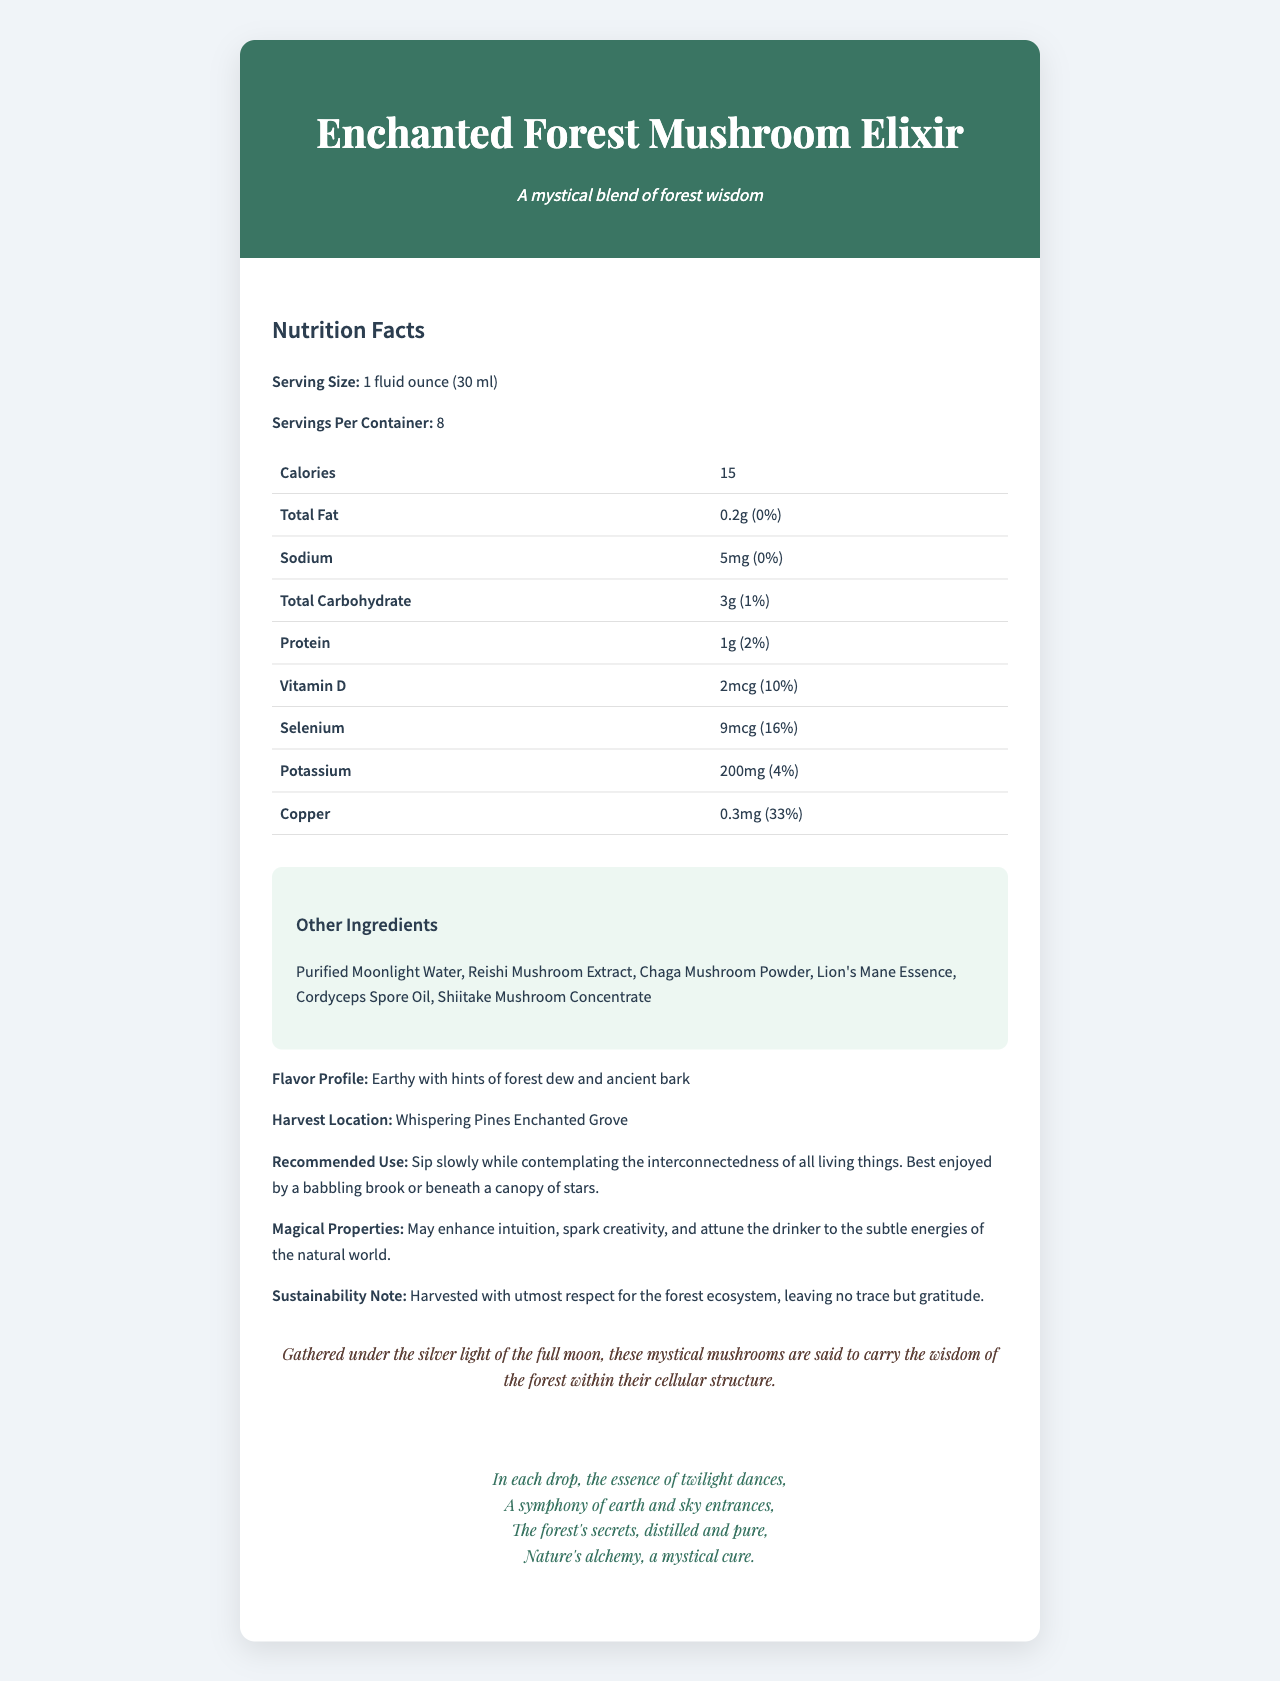What is the serving size of the Enchanted Forest Mushroom Elixir? The document lists the serving size as "1 fluid ounce (30 ml)".
Answer: 1 fluid ounce (30 ml) How many servings are there per container of the Enchanted Forest Mushroom Elixir? The document states that there are 8 servings per container.
Answer: 8 What is the calorie count per serving? The document specifies that there are 15 calories per serving.
Answer: 15 List three other ingredients in the Enchanted Forest Mushroom Elixir. These ingredients are listed under "Other Ingredients".
Answer: Purified Moonlight Water, Reishi Mushroom Extract, Chaga Mushroom Powder What are the suggested magical properties of the Enchanted Forest Mushroom Elixir? The document mentions these properties under "Magical Properties".
Answer: May enhance intuition, spark creativity, and attune the drinker to the subtle energies of the natural world. Which vitamin or mineral has the highest daily value percentage in the Enchanted Forest Mushroom Elixir? A. Vitamin D B. Selenium C. Potassium D. Copper The document shows that Copper has a daily value of 33%, which is the highest among the listed vitamins and minerals.
Answer: D. Copper How much protein is present per serving of the Enchanted Forest Mushroom Elixir? A. 0.2g B. 1g C. 2mcg D. 200mg The document lists 1 gram of protein per serving.
Answer: B. 1g Does the Enchanted Forest Mushroom Elixir contain fiber? The nutrition facts do not mention fiber.
Answer: No Is harvesting the Enchanted Forest Mushroom Elixir done sustainably? The sustainability note states that it was harvested with utmost respect for the forest ecosystem, leaving no trace but gratitude.
Answer: Yes Summarize the Enchanted Forest Mushroom Elixir document. The document details the nutritional information, ingredients, flavor profile, and magical properties of the Enchanted Forest Mushroom Elixir. It highlights sustainable practices and presents the product with an aura of enchantment.
Answer: The Enchanted Forest Mushroom Elixir is a mystical beverage made from forest mushrooms, providing a blend of vitamins and minerals with minimal calories. Each serving is 1 fluid ounce, with 8 servings per container. The elixir contains a selection of magical ingredients and is recommended for mindful sipping. It has a unique flavor profile and is sustainably harvested. The document also includes a poetic description reflecting the elixir's enchanting nature. What is the poetic description provided for the Enchanted Forest Mushroom Elixir? This can be found under the section titled "Poetic Description".
Answer: In each drop, the essence of twilight dances,
A symphony of earth and sky entrances,
The forest's secrets, distilled and pure,
Nature's alchemy, a mystical cure. What is the main harvest location for the ingredients in the Enchanted Forest Mushroom Elixir? The harvest location is stated as "Whispering Pines Enchanted Grove".
Answer: Whispering Pines Enchanted Grove What are the recommended uses for the Enchanted Forest Mushroom Elixir? The recommended use is described in that specific section of the document.
Answer: Sip slowly while contemplating the interconnectedness of all living things. Best enjoyed by a babbling brook or beneath a canopy of stars. Can the document tell us the exact amount of Vitamin C present in the elixir? The document does not provide information about the presence or amount of Vitamin C.
Answer: Cannot be determined 